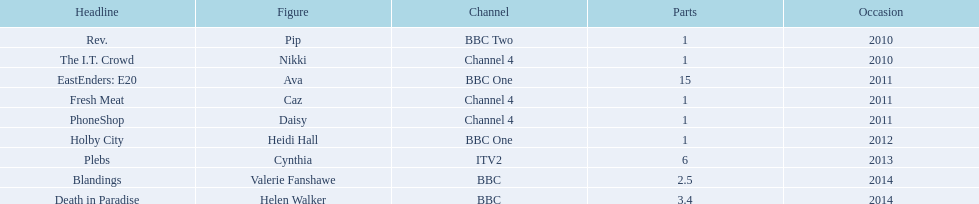Which characters were featured in more then one episode? Ava, Cynthia, Valerie Fanshawe, Helen Walker. Which of these were not in 2014? Ava, Cynthia. Which one of those was not on a bbc broadcaster? Cynthia. 